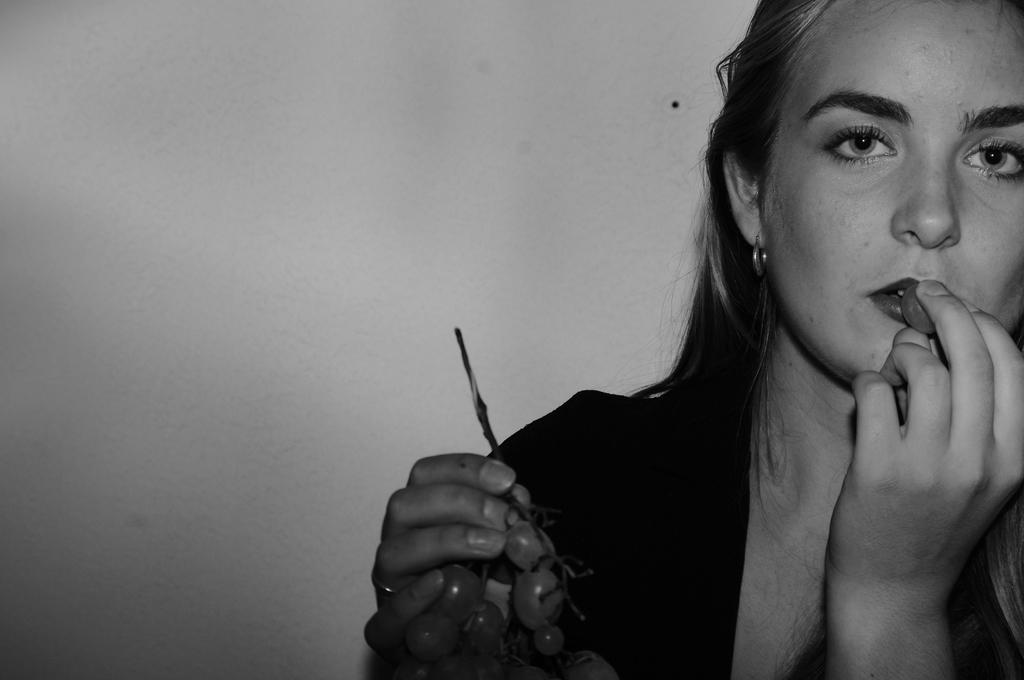What is the color scheme of the image? The image is in black and white. Who is present in the image? There is a woman in the image. What is the woman holding in the image? The woman is holding grapes. What credit score does the woman have in the image? There is no information about the woman's credit score in the image, as it is not relevant to the visual content. 